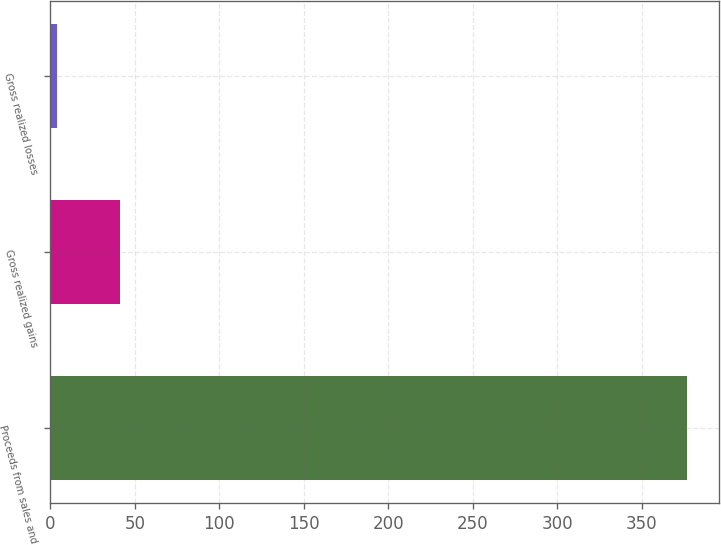Convert chart to OTSL. <chart><loc_0><loc_0><loc_500><loc_500><bar_chart><fcel>Proceeds from sales and<fcel>Gross realized gains<fcel>Gross realized losses<nl><fcel>377<fcel>41.3<fcel>4<nl></chart> 